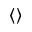Convert formula to latex. <formula><loc_0><loc_0><loc_500><loc_500>\langle \rangle</formula> 